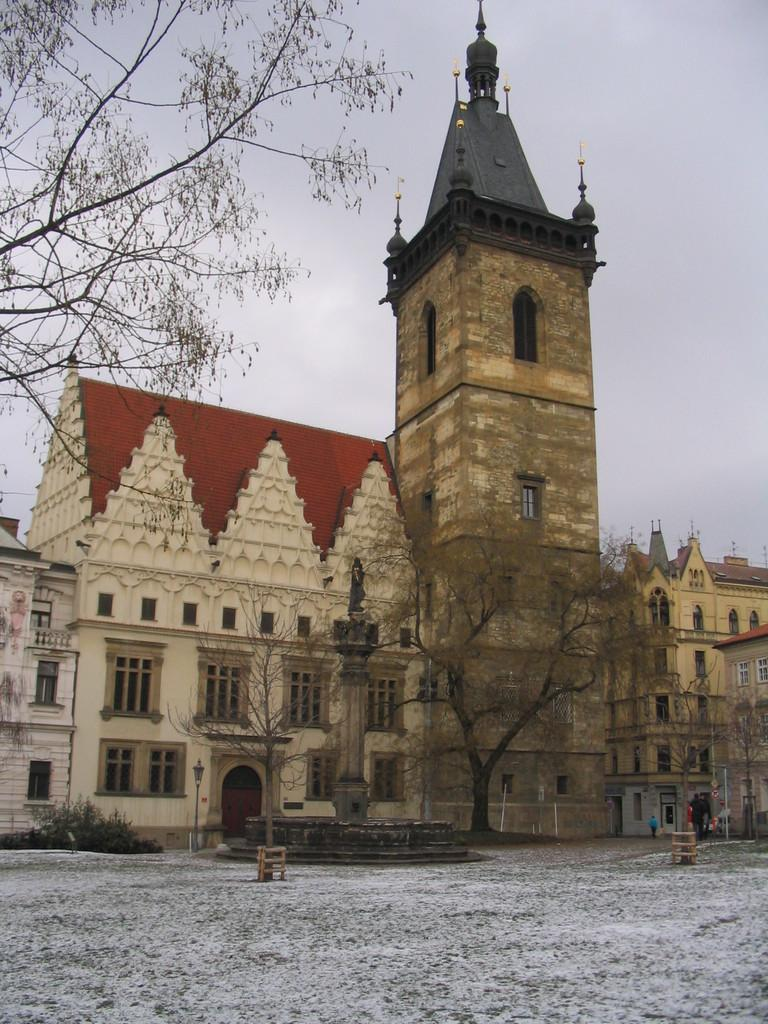What is the weather like in the image? The weather in the image is characterized by snow. What type of natural elements can be seen in the image? Trees, plants, and the sky are visible in the image. What man-made structures are present in the image? There is a statue, a light on a pole, and buildings in the image. Can you see a giraffe wearing a veil in the image? No, there is no giraffe or veil present in the image. How does the statue maintain its balance in the snow? The statue does not need to maintain its balance in the image, as it is a stationary object. 